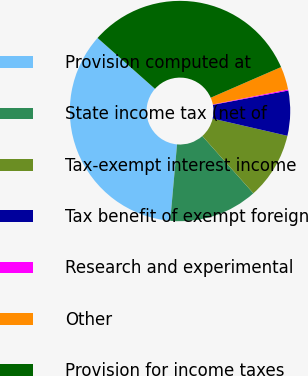<chart> <loc_0><loc_0><loc_500><loc_500><pie_chart><fcel>Provision computed at<fcel>State income tax (net of<fcel>Tax-exempt interest income<fcel>Tax benefit of exempt foreign<fcel>Research and experimental<fcel>Other<fcel>Provision for income taxes<nl><fcel>35.12%<fcel>13.01%<fcel>9.8%<fcel>6.59%<fcel>0.17%<fcel>3.38%<fcel>31.92%<nl></chart> 